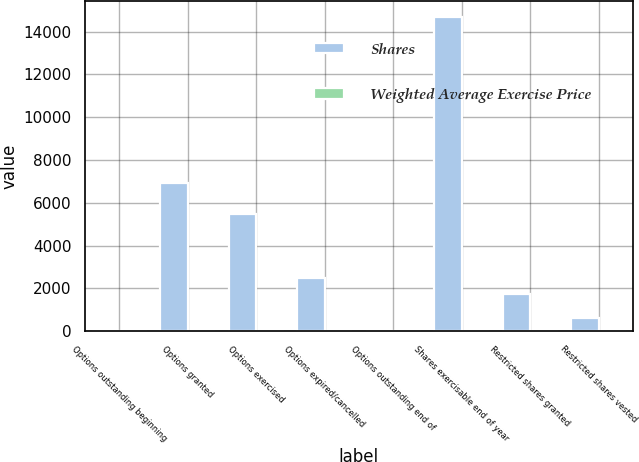Convert chart. <chart><loc_0><loc_0><loc_500><loc_500><stacked_bar_chart><ecel><fcel>Options outstanding beginning<fcel>Options granted<fcel>Options exercised<fcel>Options expired/cancelled<fcel>Options outstanding end of<fcel>Shares exercisable end of year<fcel>Restricted shares granted<fcel>Restricted shares vested<nl><fcel>Shares<fcel>27.9<fcel>6918<fcel>5479<fcel>2494<fcel>27.9<fcel>14693<fcel>1745<fcel>616<nl><fcel>Weighted Average Exercise Price<fcel>19.02<fcel>29.11<fcel>18.17<fcel>24.04<fcel>21.4<fcel>18.51<fcel>26.69<fcel>22.96<nl></chart> 